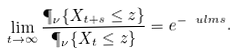<formula> <loc_0><loc_0><loc_500><loc_500>\lim _ { t \to \infty } \frac { \P _ { \nu } \{ X _ { t + s } \leq z \} } { \P _ { \nu } \{ X _ { t } \leq z \} } = e ^ { - \ u l m s } .</formula> 